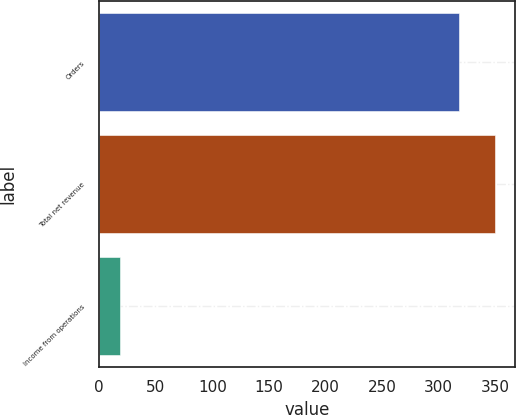<chart> <loc_0><loc_0><loc_500><loc_500><bar_chart><fcel>Orders<fcel>Total net revenue<fcel>Income from operations<nl><fcel>318<fcel>350.2<fcel>18<nl></chart> 